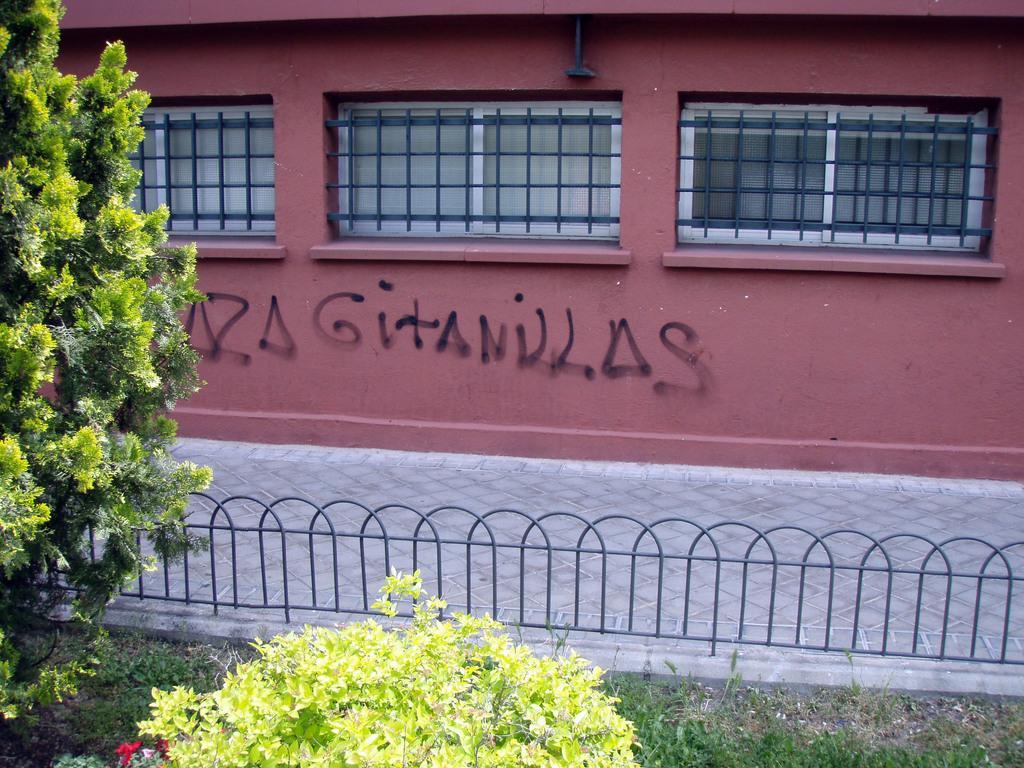Could you give a brief overview of what you see in this image? In the picture I can see the grass, a plant, a tree, fence and a building. On the building I can see something written on it. 